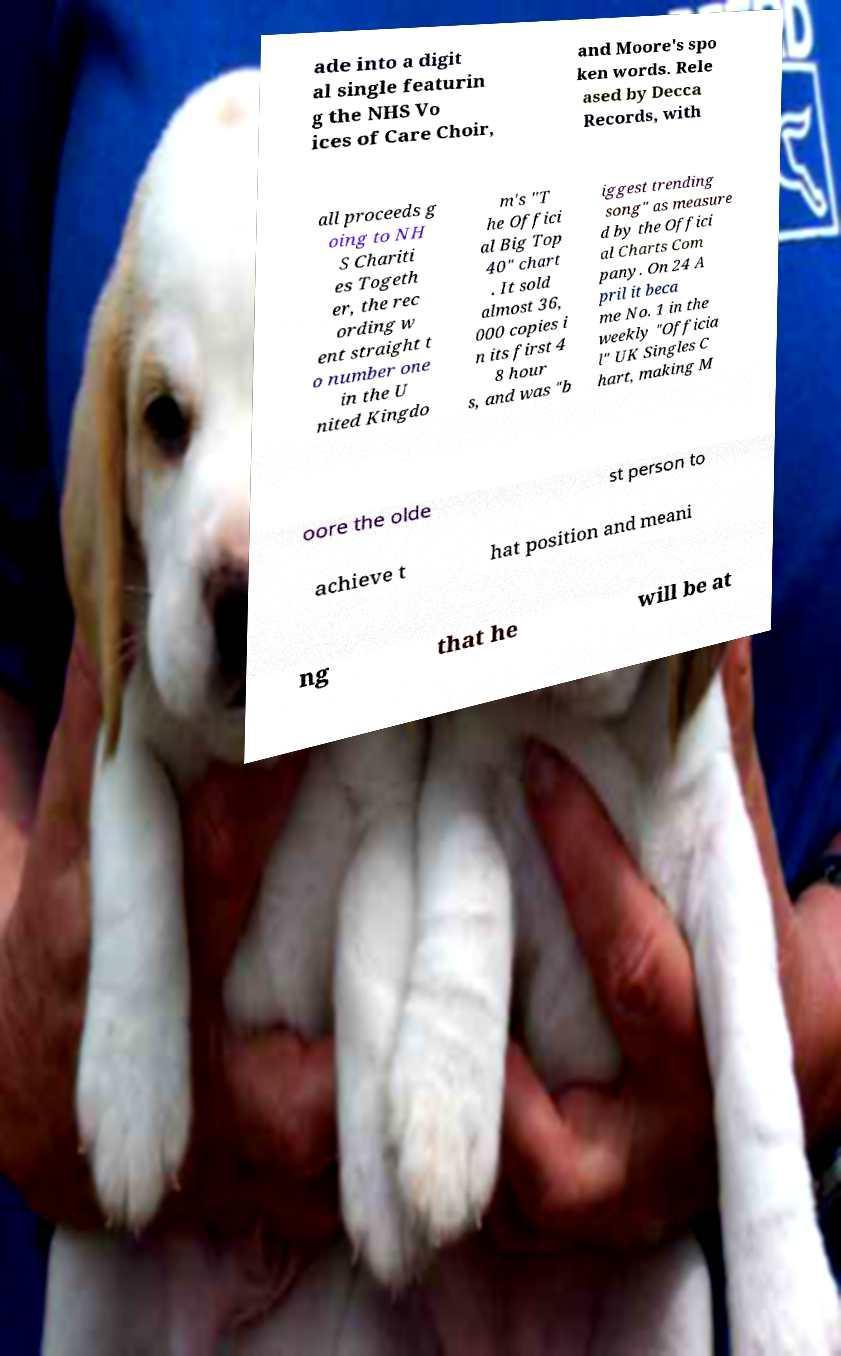Can you read and provide the text displayed in the image?This photo seems to have some interesting text. Can you extract and type it out for me? ade into a digit al single featurin g the NHS Vo ices of Care Choir, and Moore's spo ken words. Rele ased by Decca Records, with all proceeds g oing to NH S Chariti es Togeth er, the rec ording w ent straight t o number one in the U nited Kingdo m's "T he Offici al Big Top 40" chart . It sold almost 36, 000 copies i n its first 4 8 hour s, and was "b iggest trending song" as measure d by the Offici al Charts Com pany. On 24 A pril it beca me No. 1 in the weekly "Officia l" UK Singles C hart, making M oore the olde st person to achieve t hat position and meani ng that he will be at 